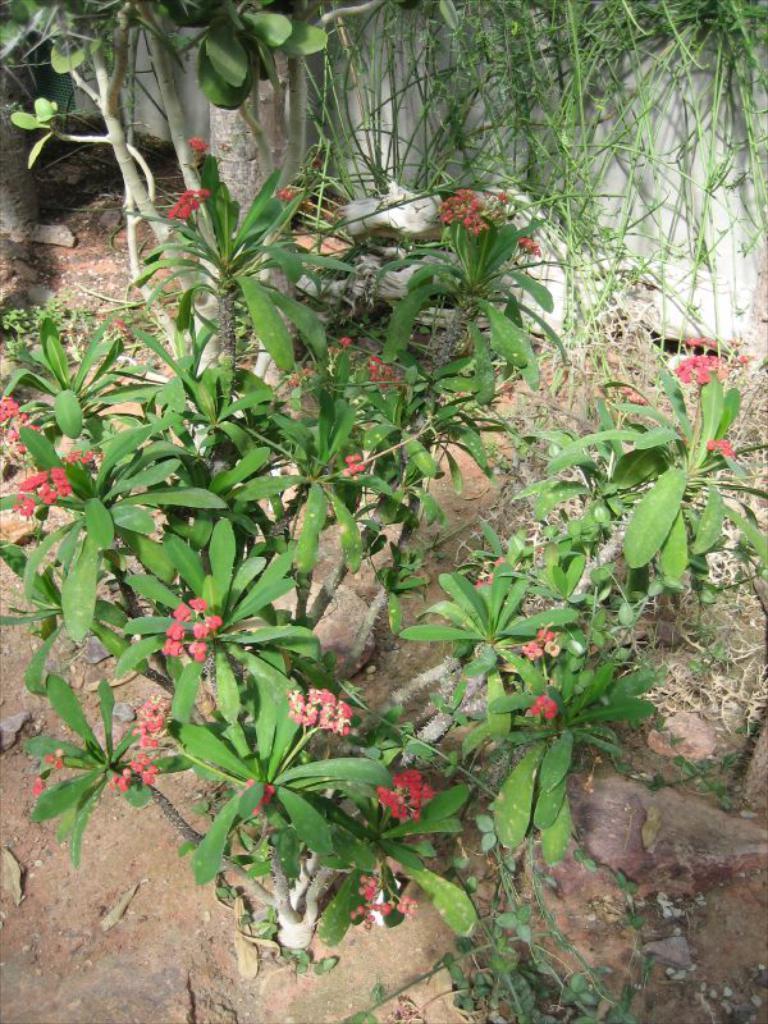How would you summarize this image in a sentence or two? In this picture there are red color flowers on the plant and there are different types of plants. At the bottom there is mud and there are stones. At the back there is a wall. 